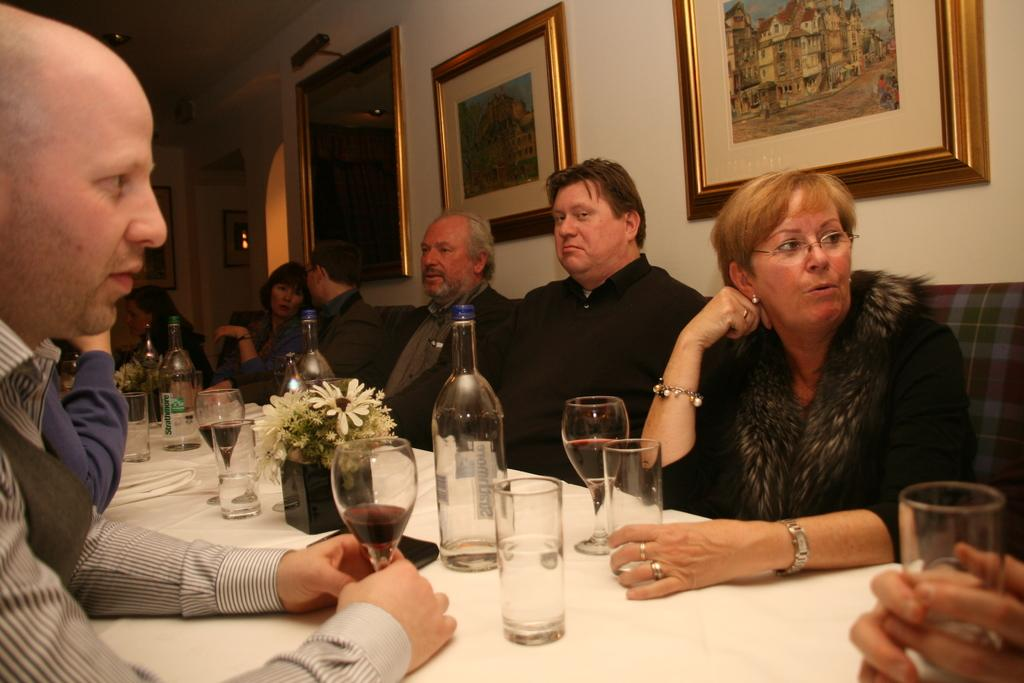What are the people in the image doing? The people in the image are sitting on sofas. What is in front of the sofas? There is a table in front of the sofas. What items can be seen on the table? There are glasses, bottles, and a small plant on the table. What is on the wall in the image? There are photos on the wall. What type of wool can be seen in the image? There is no wool present in the image. How is the grain being used in the image? There is no grain present in the image. 